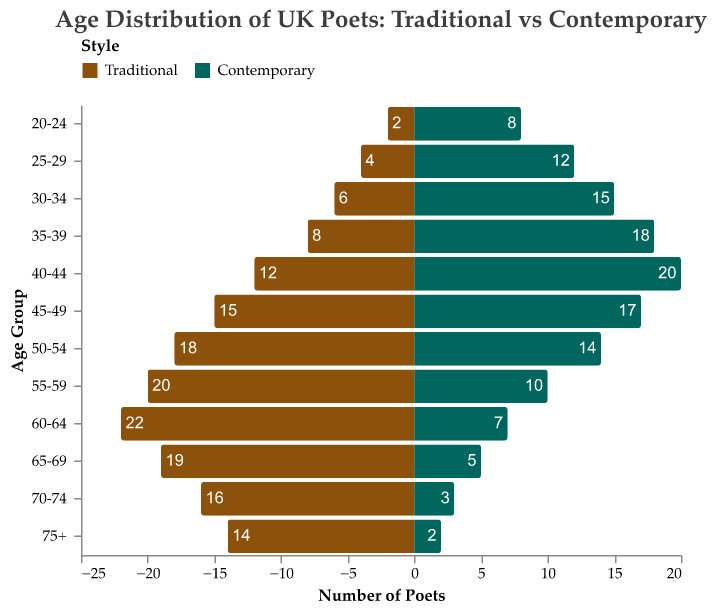Which age group has the most contemporary poets? Identify the age groups on the y-axis and observe the bar lengths associated with contemporary poets. The 40-44 age group has the longest bar, indicating the highest number of contemporary poets.
Answer: 40-44 What is the combined total of traditional poets in the 55-59 and 60-64 age groups? Look at the number of traditional poets for the 55-59 (20) and 60-64 (22) age groups. Add these two values together.
Answer: 42 Which style has more poets aged 30-34? Compare the lengths of the bars for traditional and contemporary poets in the 30-34 age group. The contemporary bar is longer.
Answer: Contemporary What is the difference in the number of traditional poets between the 50-54 and 70-74 age groups? Find the number of traditional poets in the 50-54 (18) and 70-74 (16) age groups. Subtract the latter from the former.
Answer: 2 In which age group do traditional poets outnumber contemporary poets the most? Compare the lengths of bars for both styles across all age groups and calculate the differences. The 60-64 age group has the highest difference (22 traditional poets versus 7 contemporary poets).
Answer: 60-64 Which age group has the fewest number of poets for both traditional and contemporary styles combined? Sum the poets of both styles across all age groups. The age group with the lowest combined total is 75+ (14 traditional + 2 contemporary = 16).
Answer: 75+ How many more contemporary poets are there than traditional poets in the 40-44 age group? Find the number of contemporary poets (20) and traditional poets (12) in the 40-44 age group. Subtract the latter from the former.
Answer: 8 What is the average number of contemporary poets across all age groups? Sum the number of contemporary poets across all age groups and divide by the number of age groups (12). The sum is 141. Average = 141 / 12.
Answer: 11.75 Do younger (20-39) or older (60-75+) contemporary poets comprise a larger group? Sum the number of contemporary poets in the younger age groups (20-39) and older age groups (60-75+). Younger (8+12+15+18) = 53, older (7+5+3+2) = 17. Compare the sums.
Answer: Younger In which age groups is the number of traditional poets equal to or greater than contemporary poets? Compare the bar lengths for each age group, noting where the traditional poets' bar is equal to or longer than the contemporary poets' bar. The age groups are 50-54, 55-59, 60-64, 65-69, 70-74, and 75+.
Answer: 50-54, 55-59, 60-64, 65-69, 70-74, 75+ 